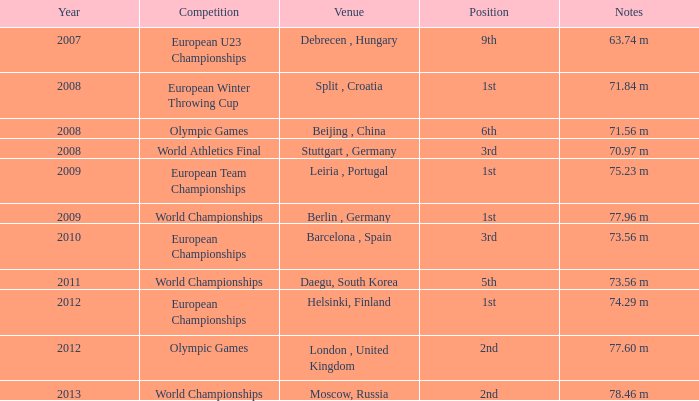Which Notes have a Competition of world championships, and a Position of 2nd? 78.46 m. 